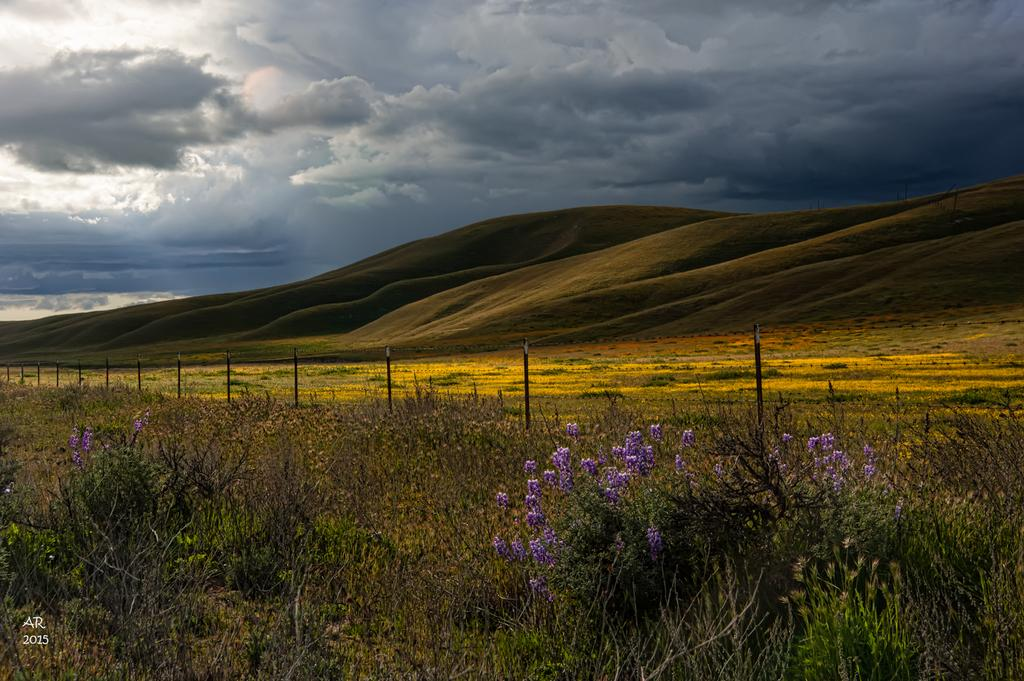What type of environment is depicted in the image? The image shows an outside view. What can be seen growing in the image? There are flowers on the plants and bushes in the image. What geographical feature is visible in the distance? There are mountains visible in the image. What is the condition of the sky in the image? The sky is clouded in the image. What type of spark can be seen coming from the duck in the image? There is no duck present in the image, so there cannot be any spark coming from it. 